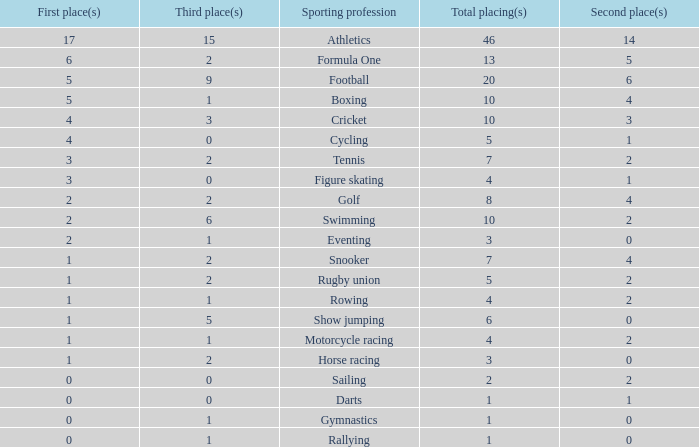How many second place showings does snooker have? 4.0. 